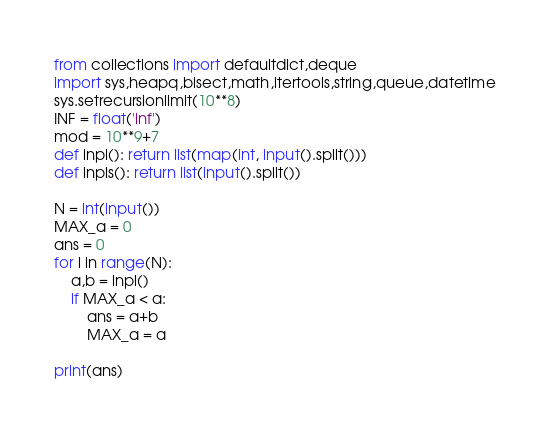<code> <loc_0><loc_0><loc_500><loc_500><_Python_>from collections import defaultdict,deque
import sys,heapq,bisect,math,itertools,string,queue,datetime
sys.setrecursionlimit(10**8)
INF = float('inf')
mod = 10**9+7
def inpl(): return list(map(int, input().split()))
def inpls(): return list(input().split())

N = int(input())
MAX_a = 0
ans = 0
for i in range(N):
	a,b = inpl()
	if MAX_a < a:
		ans = a+b
		MAX_a = a

print(ans)
</code> 